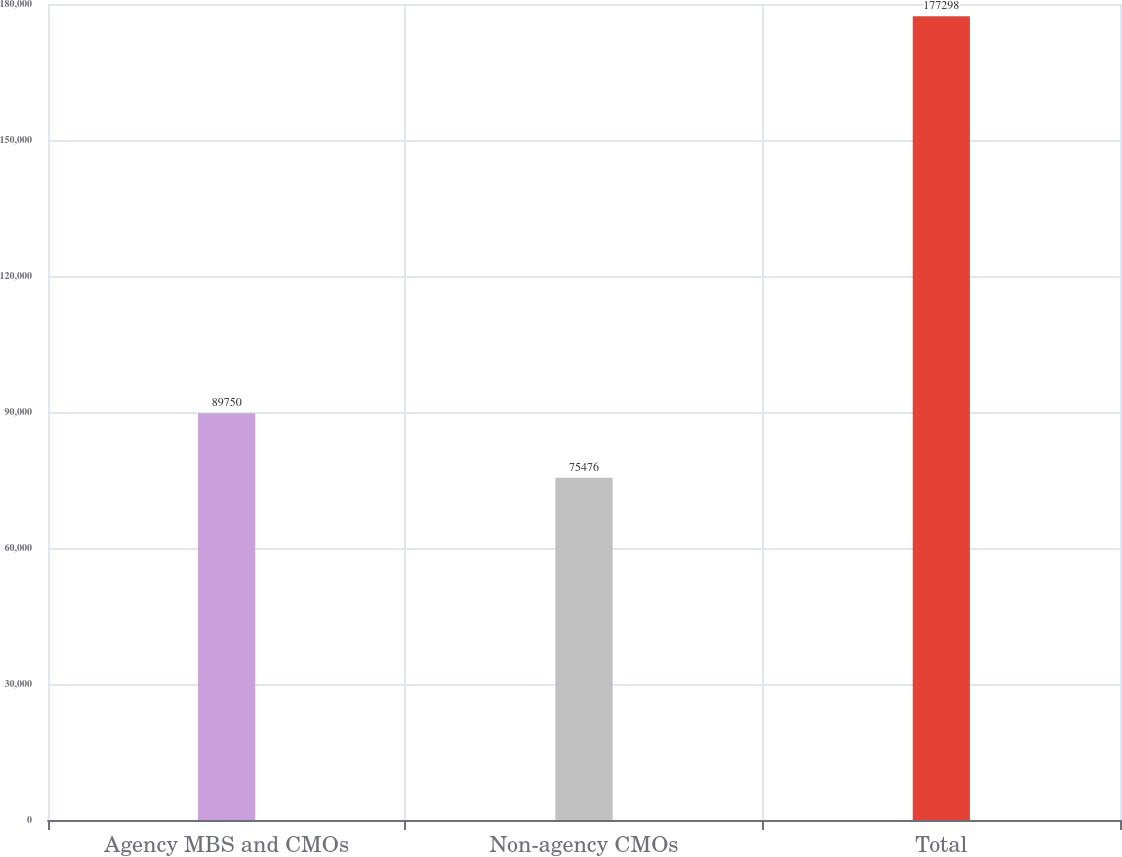Convert chart to OTSL. <chart><loc_0><loc_0><loc_500><loc_500><bar_chart><fcel>Agency MBS and CMOs<fcel>Non-agency CMOs<fcel>Total<nl><fcel>89750<fcel>75476<fcel>177298<nl></chart> 